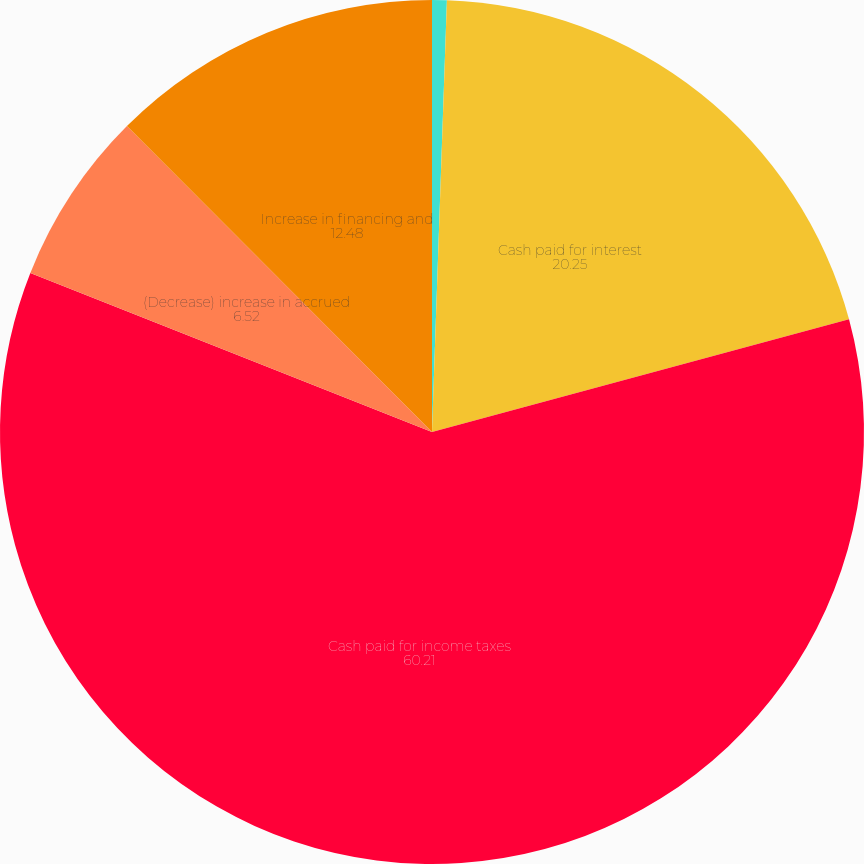Convert chart to OTSL. <chart><loc_0><loc_0><loc_500><loc_500><pie_chart><fcel>(In thousands)<fcel>Cash paid for interest<fcel>Cash paid for income taxes<fcel>(Decrease) increase in accrued<fcel>Increase in financing and<nl><fcel>0.55%<fcel>20.25%<fcel>60.21%<fcel>6.52%<fcel>12.48%<nl></chart> 